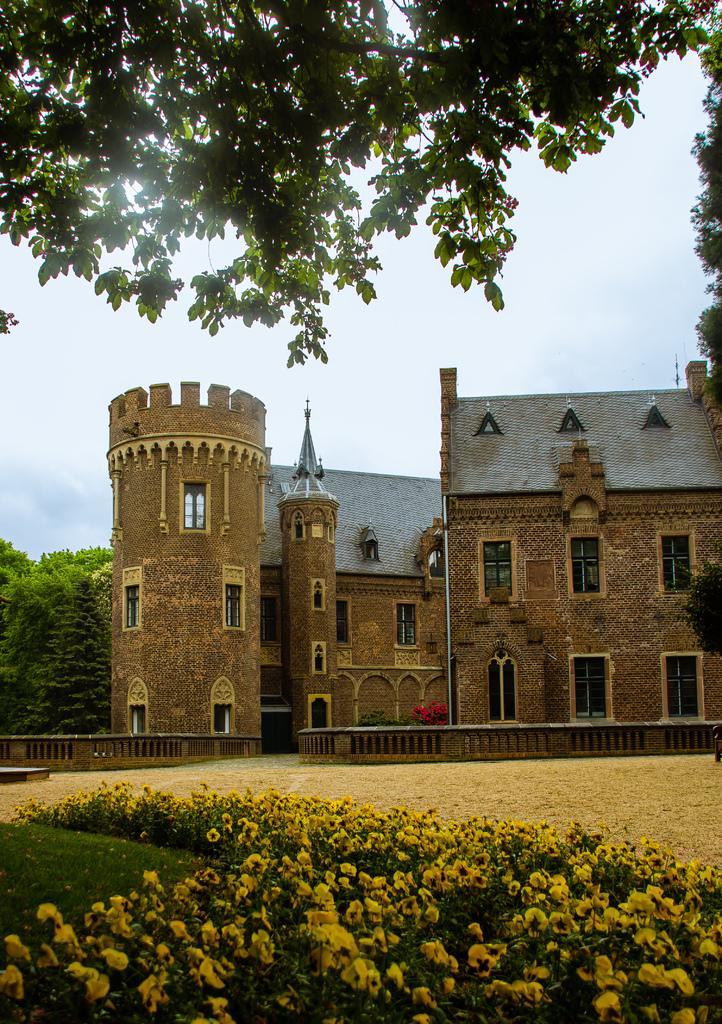What type of vegetation can be seen on the ground in the image? There are flowers on the ground in the image. What type of structure is visible in the image? There is a building visible in the image. What can be seen in the background of the image? There are many trees at the back of the image. What type of organization is conducting a meeting near the river in the image? There is no river or meeting present in the image; it features flowers on the ground, a building, and many trees in the background. What advice does the minister give to the congregation in the image? There is no minister or congregation present in the image. 